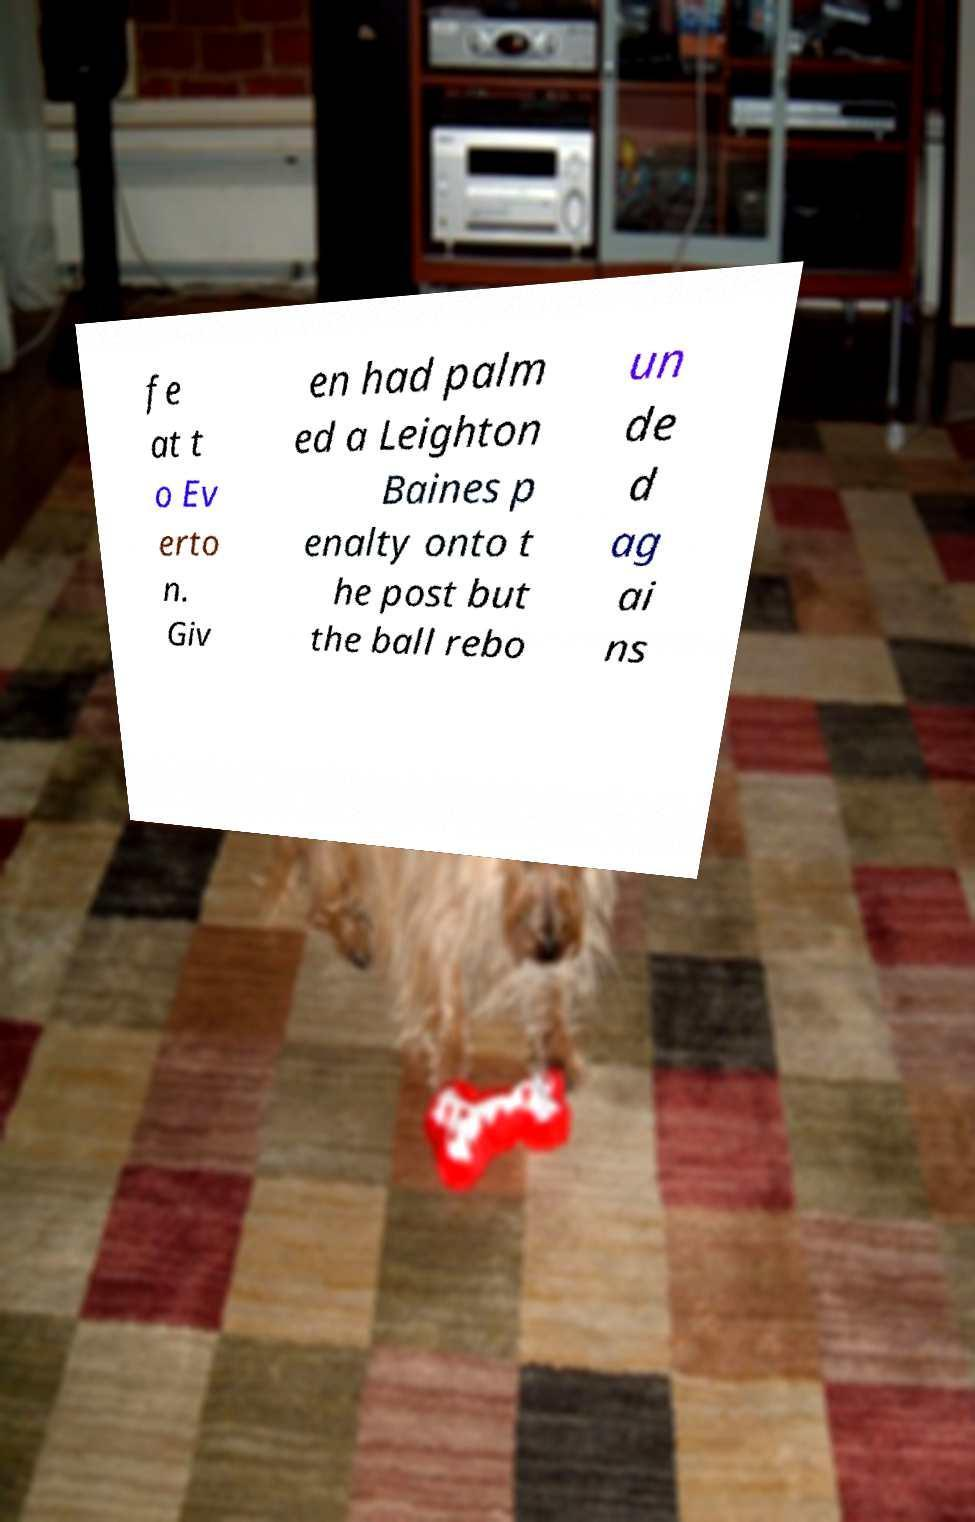I need the written content from this picture converted into text. Can you do that? fe at t o Ev erto n. Giv en had palm ed a Leighton Baines p enalty onto t he post but the ball rebo un de d ag ai ns 